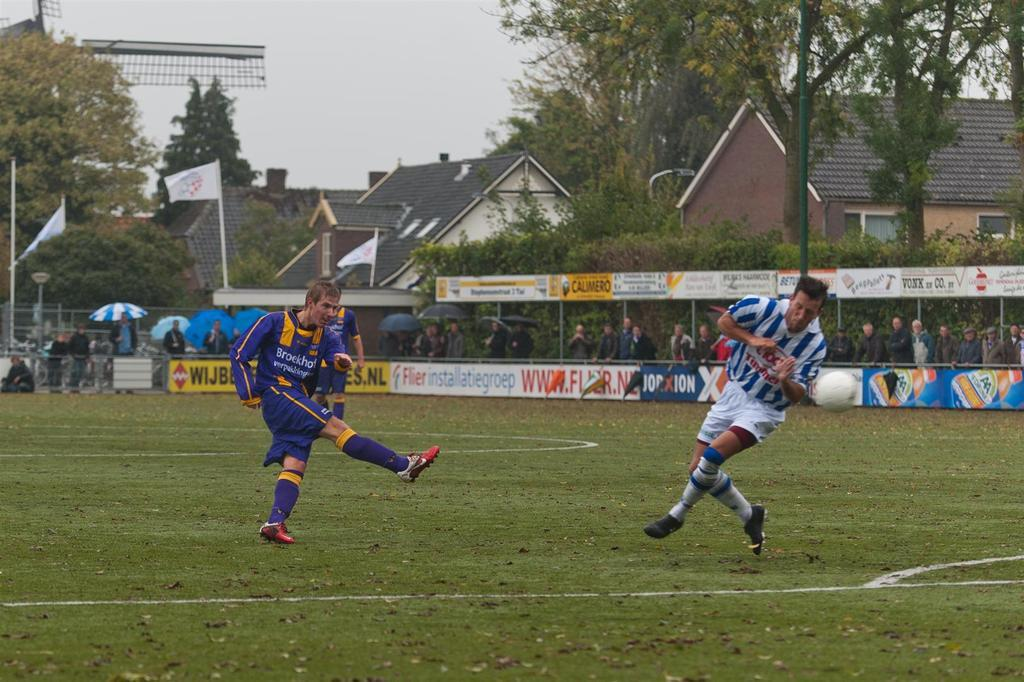<image>
Share a concise interpretation of the image provided. People on a sports field with a sign reading WIJB behind them. 